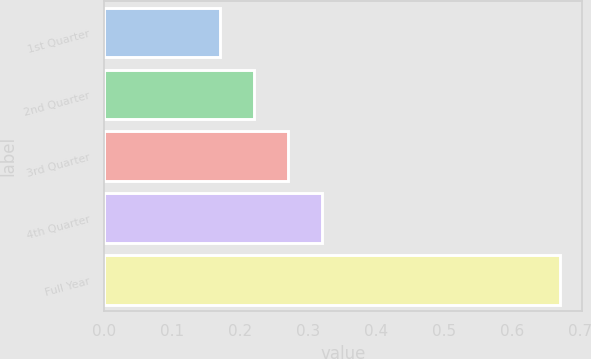Convert chart. <chart><loc_0><loc_0><loc_500><loc_500><bar_chart><fcel>1st Quarter<fcel>2nd Quarter<fcel>3rd Quarter<fcel>4th Quarter<fcel>Full Year<nl><fcel>0.17<fcel>0.22<fcel>0.27<fcel>0.32<fcel>0.67<nl></chart> 